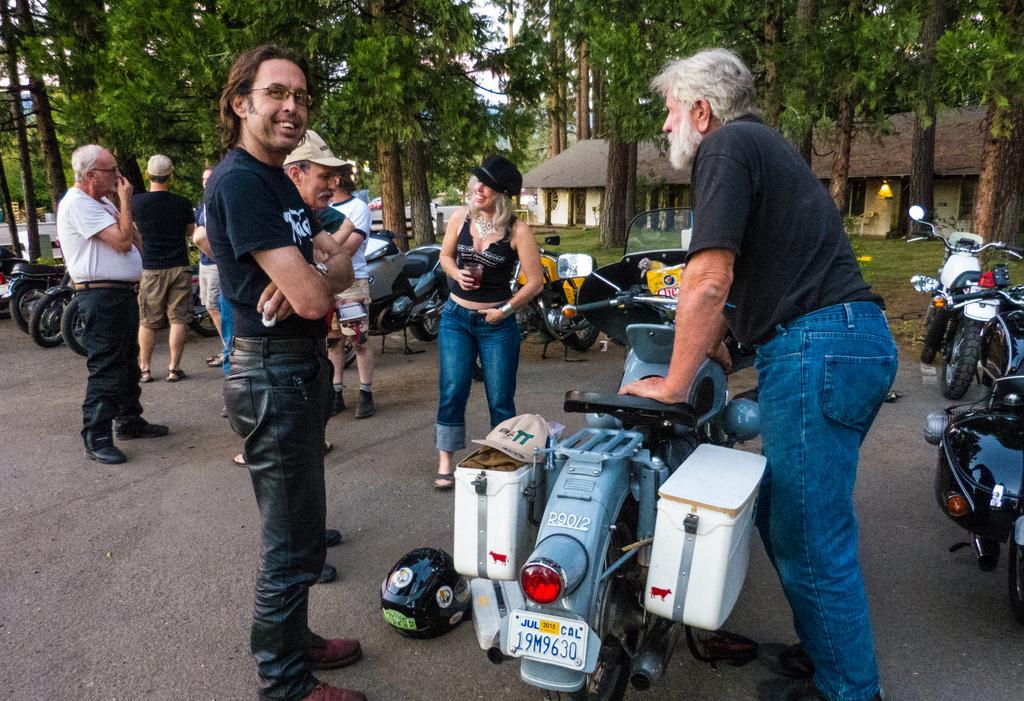Please provide a concise description of this image. In this image I can see group of people standing, in front the person is wearing black color dress and the person at right wearing black shirt, blue pant. I can also see few vehicles, in front the vehicle is in gray color. Background I can see trees in green color, a house in cream color and the sky is in white color. 